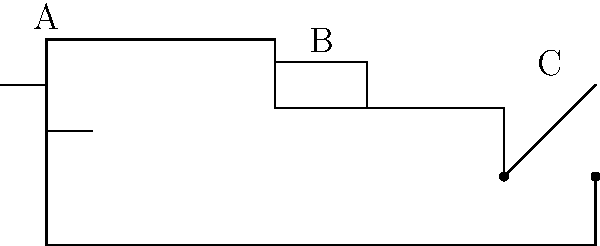Look at the electrical circuit diagram. Can you identify the components labeled A, B, and C? Let's identify each component step-by-step:

1. Component A:
   - This symbol shows two parallel lines of different lengths.
   - In electrical circuits, this represents a battery or power source.

2. Component B:
   - This symbol is a rectangle.
   - In electrical circuits, a rectangle typically represents a resistor.

3. Component C:
   - This symbol shows a line with a gap, and the upper part of the line is slanted.
   - In electrical circuits, this represents a switch.

These are basic symbols used in simple electrical circuit diagrams. Recognizing them is important for understanding how electricity flows in a circuit.
Answer: A: Battery, B: Resistor, C: Switch 